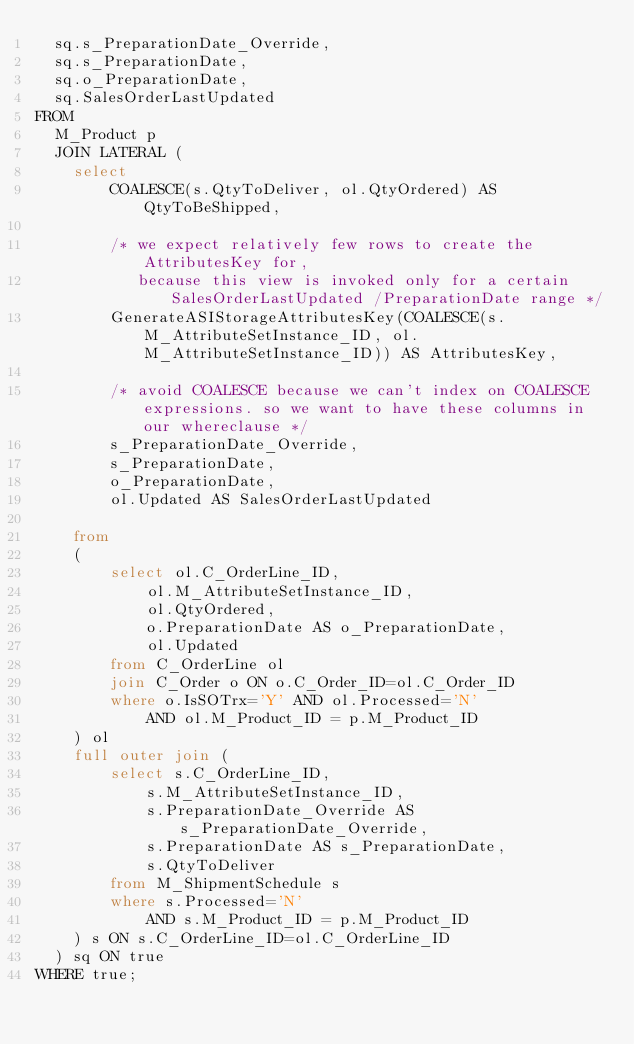<code> <loc_0><loc_0><loc_500><loc_500><_SQL_>  sq.s_PreparationDate_Override,
  sq.s_PreparationDate, 
  sq.o_PreparationDate,
  sq.SalesOrderLastUpdated
FROM
  M_Product p
  JOIN LATERAL (
    select 
        COALESCE(s.QtyToDeliver, ol.QtyOrdered) AS QtyToBeShipped,

        /* we expect relatively few rows to create the AttributesKey for, 
           because this view is invoked only for a certain SalesOrderLastUpdated /PreparationDate range */
        GenerateASIStorageAttributesKey(COALESCE(s.M_AttributeSetInstance_ID, ol.M_AttributeSetInstance_ID)) AS AttributesKey,

        /* avoid COALESCE because we can't index on COALESCE expressions. so we want to have these columns in our whereclause */
        s_PreparationDate_Override,
        s_PreparationDate, 
        o_PreparationDate,
        ol.Updated AS SalesOrderLastUpdated

    from 
    ( 
        select ol.C_OrderLine_ID, 
            ol.M_AttributeSetInstance_ID, 
            ol.QtyOrdered, 
            o.PreparationDate AS o_PreparationDate, 
            ol.Updated
        from C_OrderLine ol
        join C_Order o ON o.C_Order_ID=ol.C_Order_ID
        where o.IsSOTrx='Y' AND ol.Processed='N'
            AND ol.M_Product_ID = p.M_Product_ID
    ) ol
    full outer join (
        select s.C_OrderLine_ID, 
            s.M_AttributeSetInstance_ID, 
            s.PreparationDate_Override AS s_PreparationDate_Override, 
            s.PreparationDate AS s_PreparationDate, 
            s.QtyToDeliver
        from M_ShipmentSchedule s
        where s.Processed='N'
            AND s.M_Product_ID = p.M_Product_ID
    ) s ON s.C_OrderLine_ID=ol.C_OrderLine_ID
  ) sq ON true
WHERE true;
</code> 